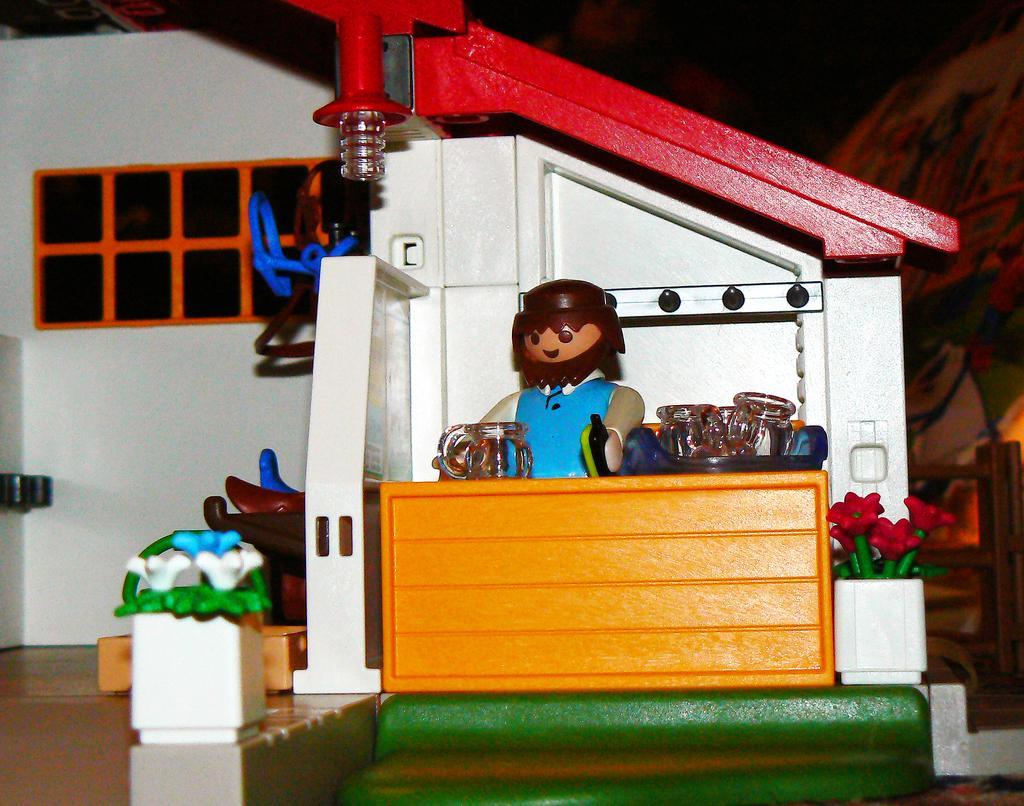Please provide a concise description of this image. In the center of the image we can see a toy house. 